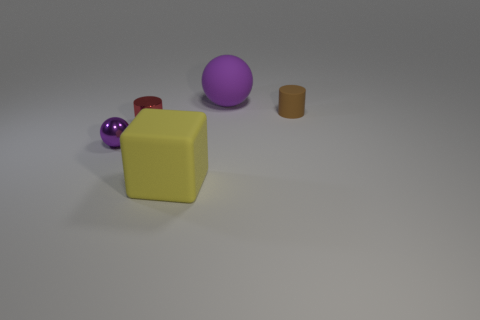Add 3 tiny gray matte blocks. How many objects exist? 8 Subtract all blocks. How many objects are left? 4 Subtract 1 cubes. How many cubes are left? 0 Subtract all green cubes. Subtract all blue cylinders. How many cubes are left? 1 Add 2 tiny brown rubber things. How many tiny brown rubber things are left? 3 Add 5 brown objects. How many brown objects exist? 6 Subtract 0 blue blocks. How many objects are left? 5 Subtract all red metal cylinders. Subtract all small brown objects. How many objects are left? 3 